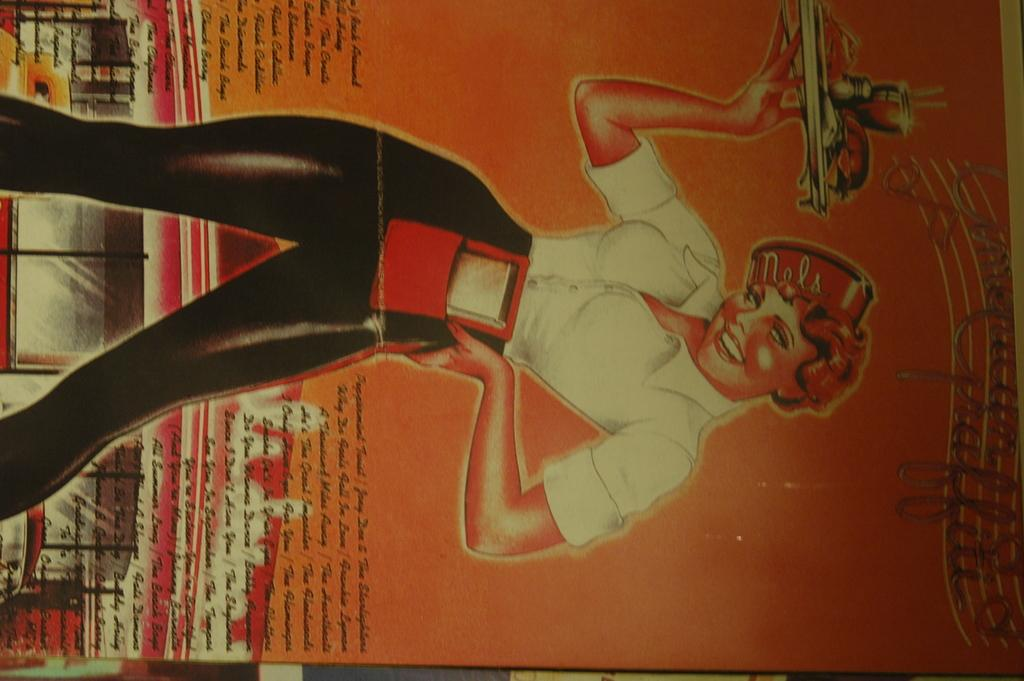What is present in the image? There is a poster in the image. What can be seen on the poster? The poster contains a person holding an object. Are there any words on the poster? Yes, there is text written on the poster. What flavor of car is depicted on the poster? There is no car present on the poster, and therefore no flavor can be associated with it. 